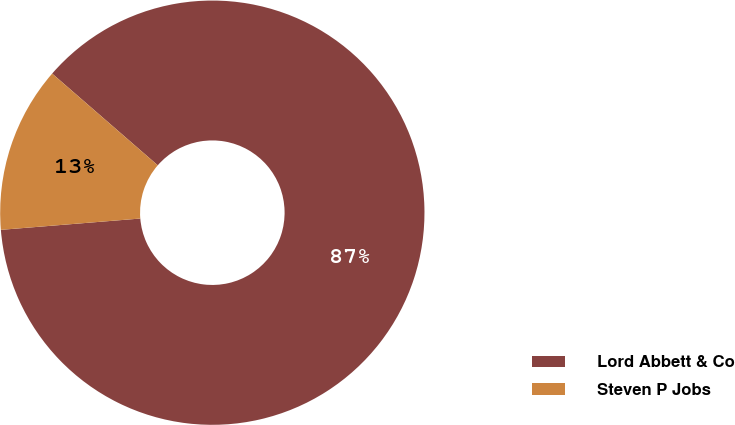<chart> <loc_0><loc_0><loc_500><loc_500><pie_chart><fcel>Lord Abbett & Co<fcel>Steven P Jobs<nl><fcel>87.33%<fcel>12.67%<nl></chart> 